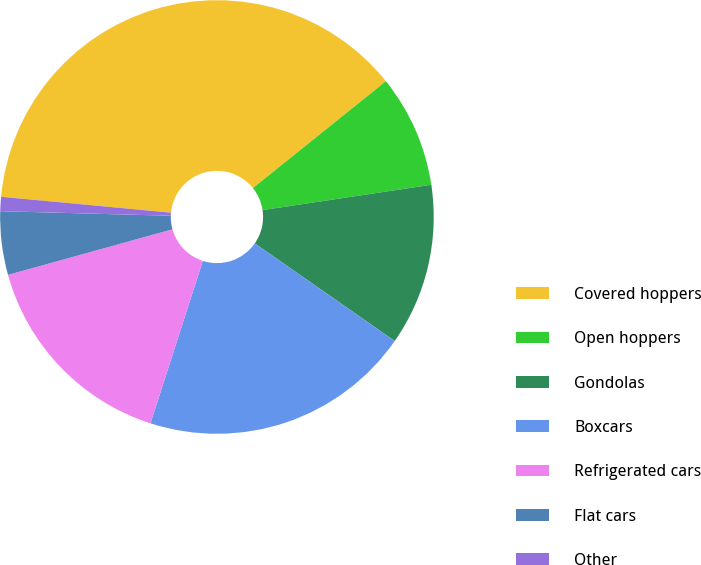<chart> <loc_0><loc_0><loc_500><loc_500><pie_chart><fcel>Covered hoppers<fcel>Open hoppers<fcel>Gondolas<fcel>Boxcars<fcel>Refrigerated cars<fcel>Flat cars<fcel>Other<nl><fcel>37.75%<fcel>8.4%<fcel>12.07%<fcel>20.27%<fcel>15.74%<fcel>4.73%<fcel>1.06%<nl></chart> 